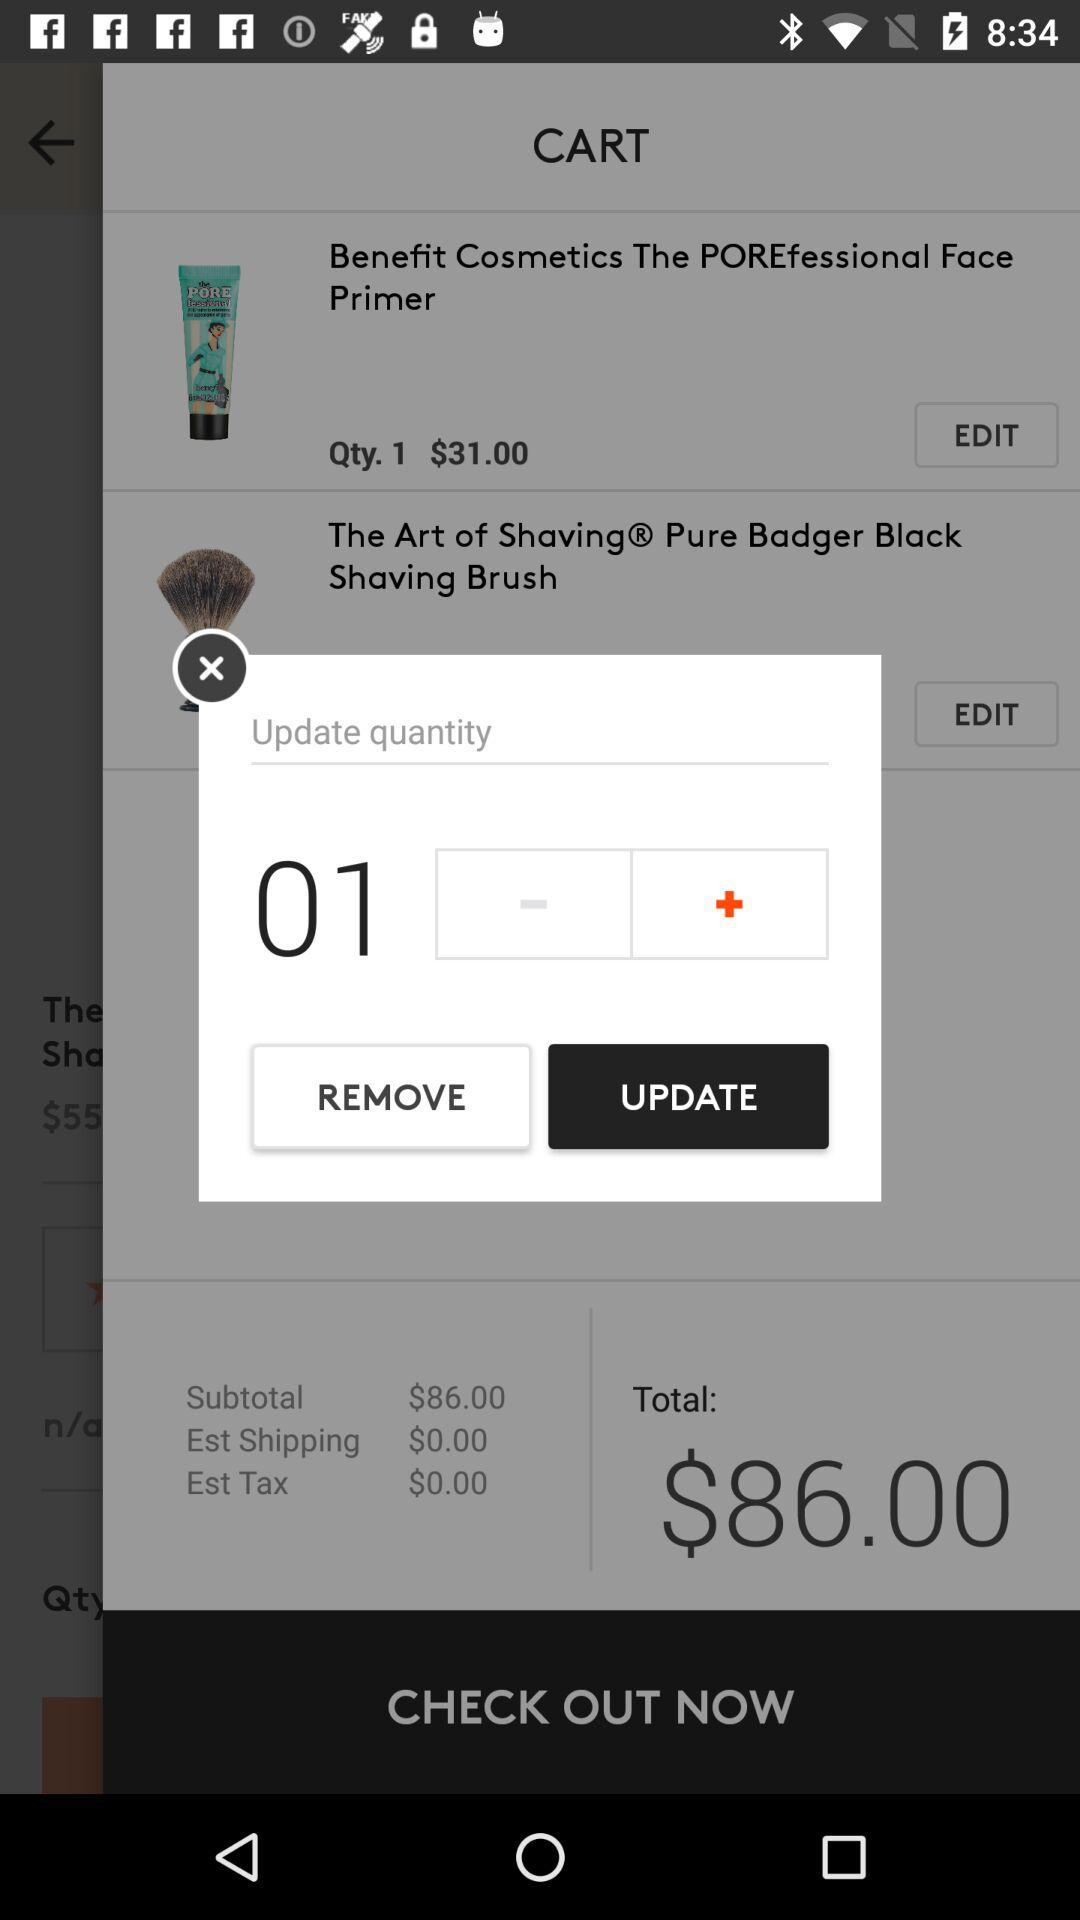What is the selected quantity? The selected quantity is 1. 